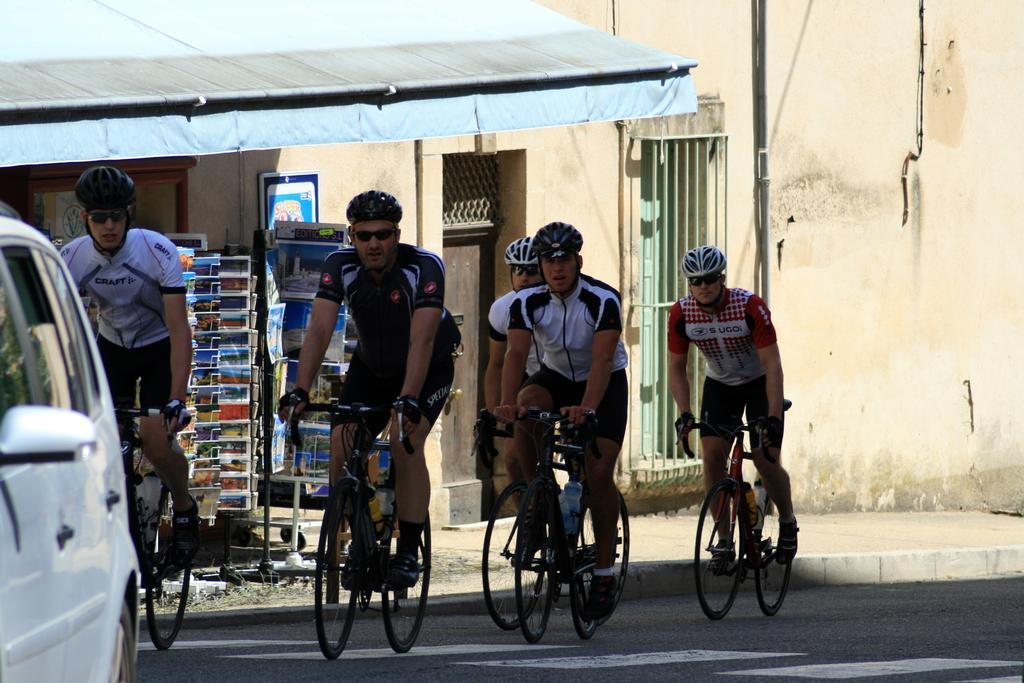Where was the image taken? The image was taken on the road. What are the people in the image doing? The people in the image are riding bicycles on the road. What vehicle is visible on the left side of the image? There is a car on the left side of the image. What can be seen in the background of the image? There is a building in the background of the image. Is there any magic happening in the image? There is no magic present in the image; it shows people riding bicycles and a car on the road. 